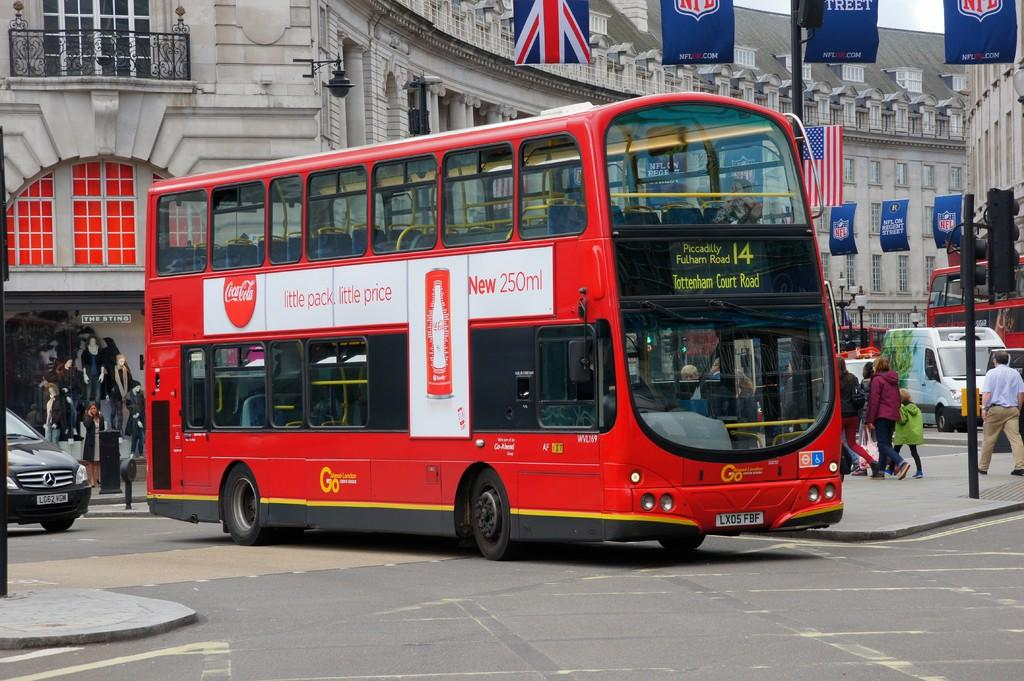What type of vehicle is in the image? There is a red double-decker bus in the image. What is the bus doing in the image? The bus is moving on the road. What is located behind the bus? There is a car behind the bus, and a cloth shop is behind the car. What can be seen in the background of the image? There is a white building and flags visible in the background. How many dolls are sitting on the bus in the image? There are no dolls present in the image; it features a red double-decker bus moving on the road. What type of jeans is the person wearing in the image? There is no person visible in the image, so it is impossible to determine what type of jeans they might be wearing. 